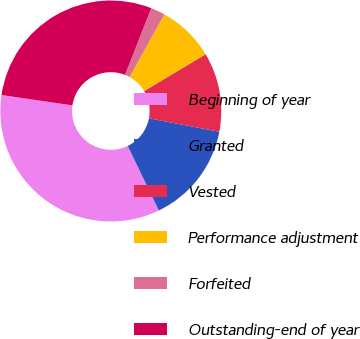<chart> <loc_0><loc_0><loc_500><loc_500><pie_chart><fcel>Beginning of year<fcel>Granted<fcel>Vested<fcel>Performance adjustment<fcel>Forfeited<fcel>Outstanding-end of year<nl><fcel>34.47%<fcel>14.83%<fcel>11.6%<fcel>8.36%<fcel>2.09%<fcel>28.65%<nl></chart> 